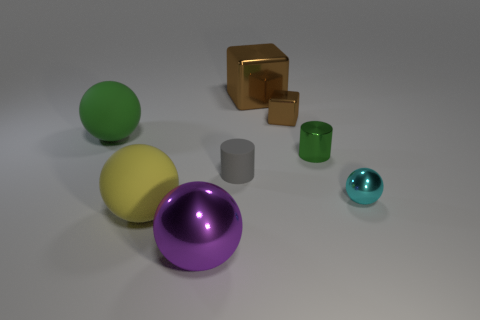Subtract 1 balls. How many balls are left? 3 Add 1 tiny cylinders. How many objects exist? 9 Subtract all cylinders. How many objects are left? 6 Subtract 0 purple cubes. How many objects are left? 8 Subtract all brown balls. Subtract all purple metal spheres. How many objects are left? 7 Add 2 large rubber balls. How many large rubber balls are left? 4 Add 4 large brown metal spheres. How many large brown metal spheres exist? 4 